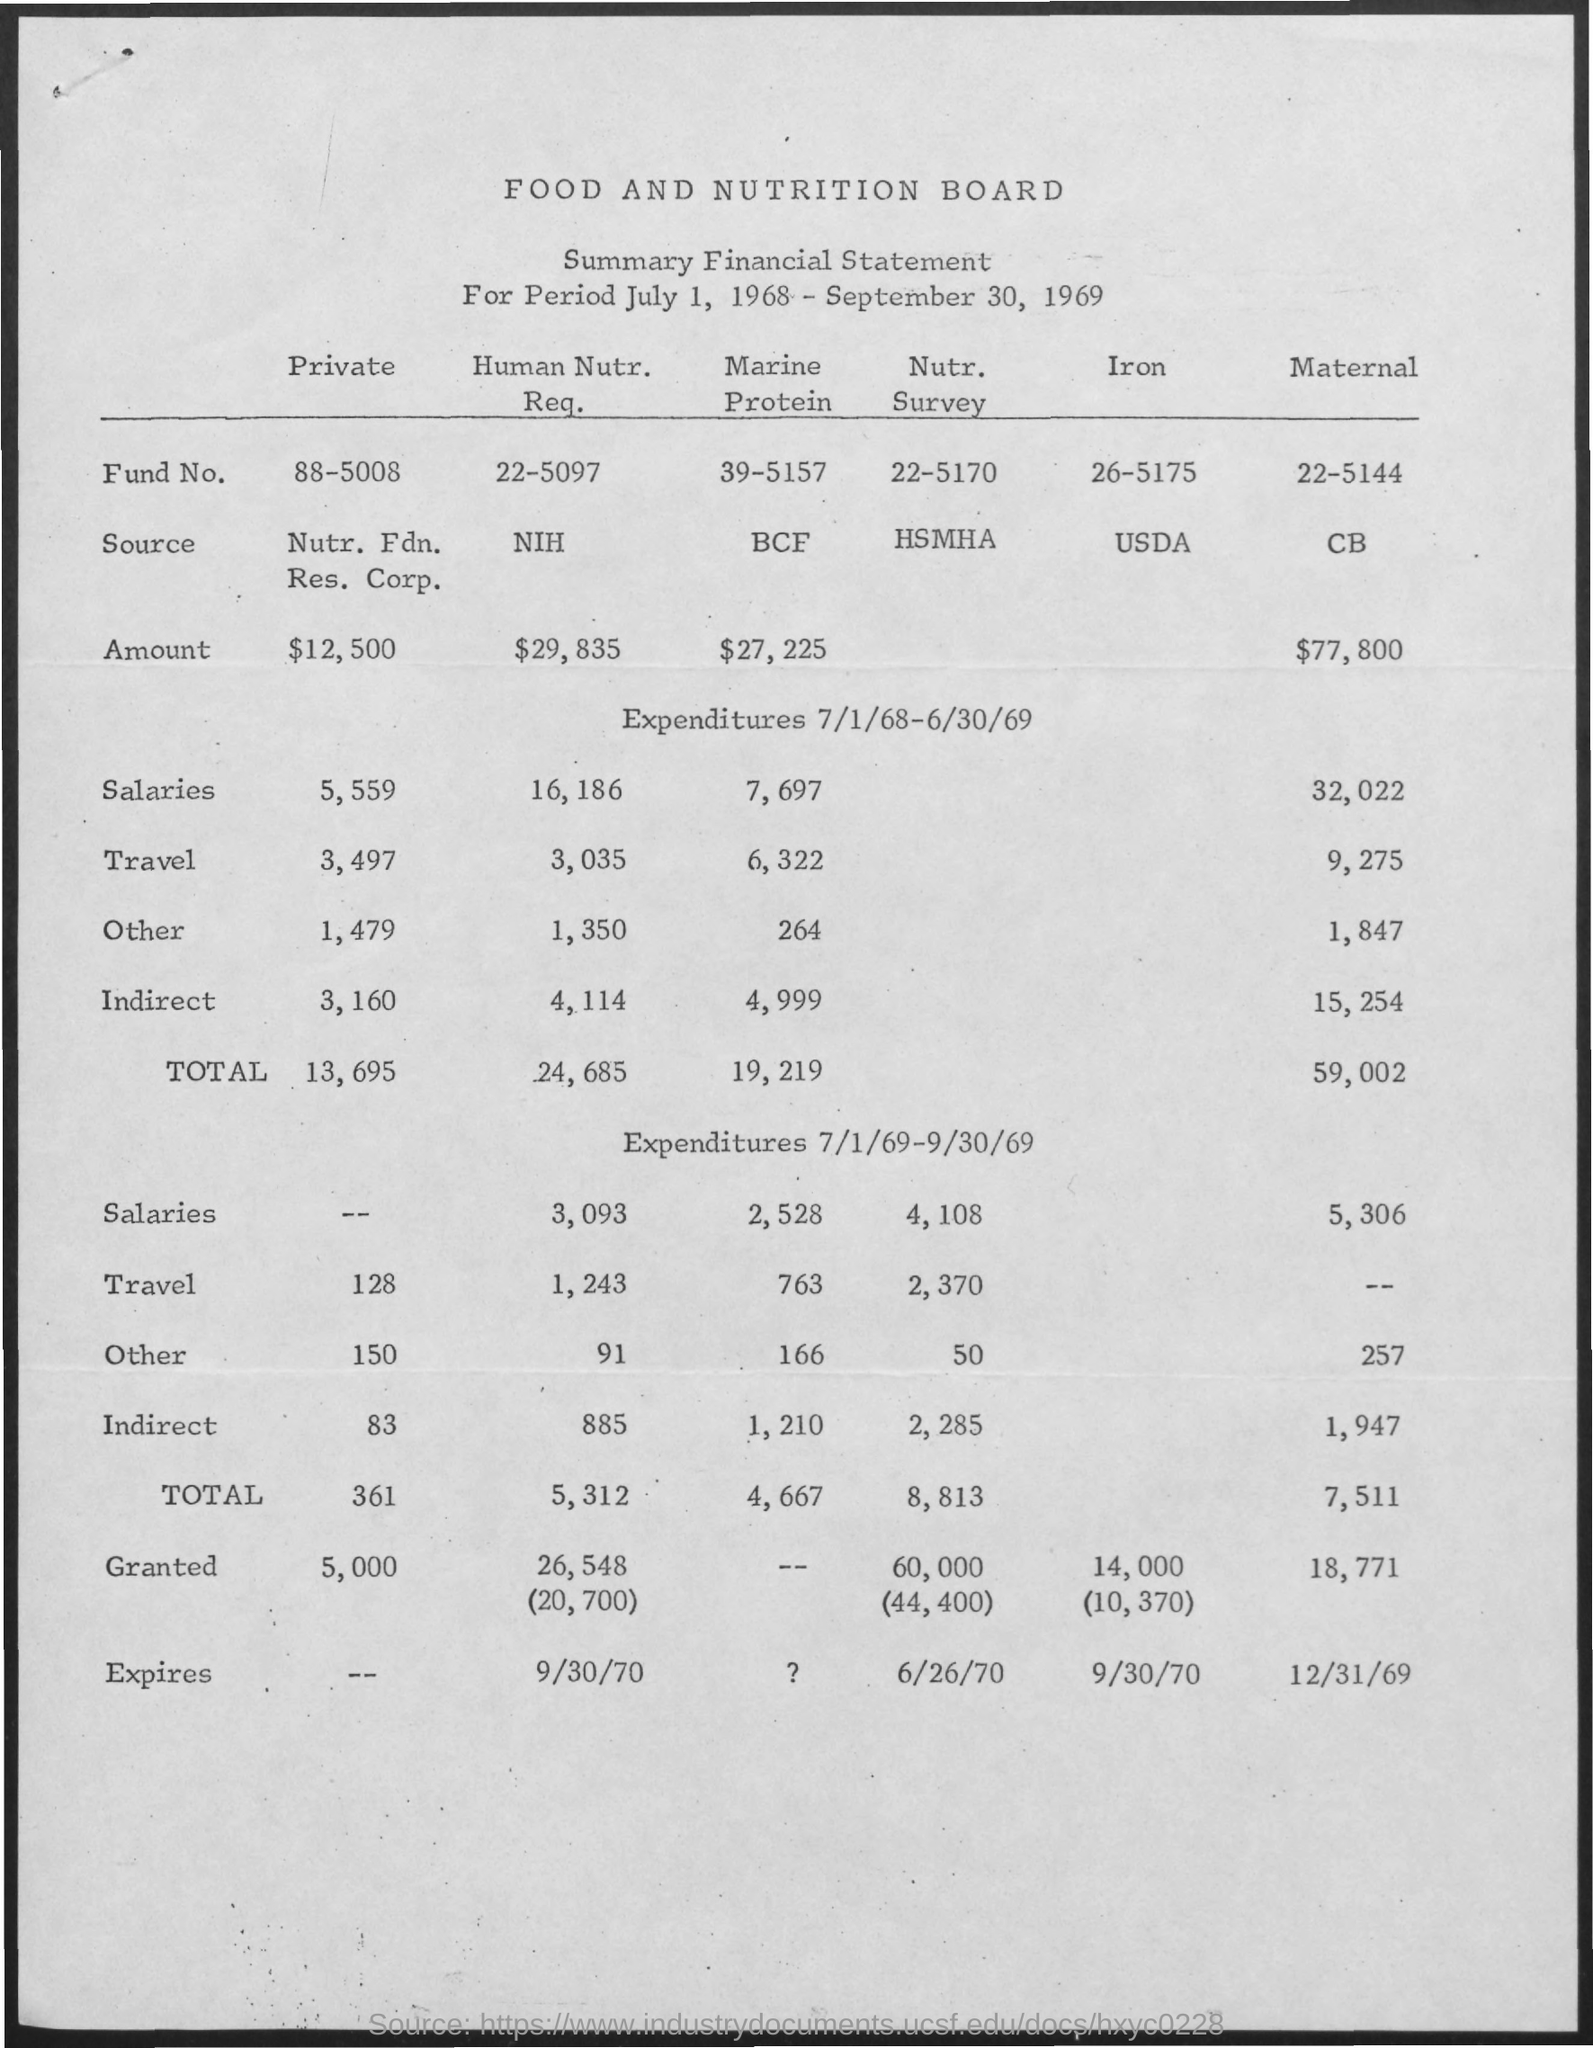What is the Title of the document?
Your answer should be compact. Food and Nutrition Board. What is the Fund No. for Human Nutr. Req.?
Make the answer very short. 22-5097. What is the Fund No. for Private?
Provide a succinct answer. 88-5008. What is the Fund No. for Marine protein?
Your answer should be compact. 39-5157. What is the Fund No. for Nutr. Survey?
Give a very brief answer. 22-5170. What is the Fund No. for Iron?
Give a very brief answer. 26-5175. What is the Fund No. for Maternal?
Ensure brevity in your answer.  22-5144. What is the Amount for Private?
Provide a succinct answer. $12,500. What is the Amount for Human Nutr. Req.?
Provide a short and direct response. $29,835. What is the Amount for Maternal?
Keep it short and to the point. $77,800. 